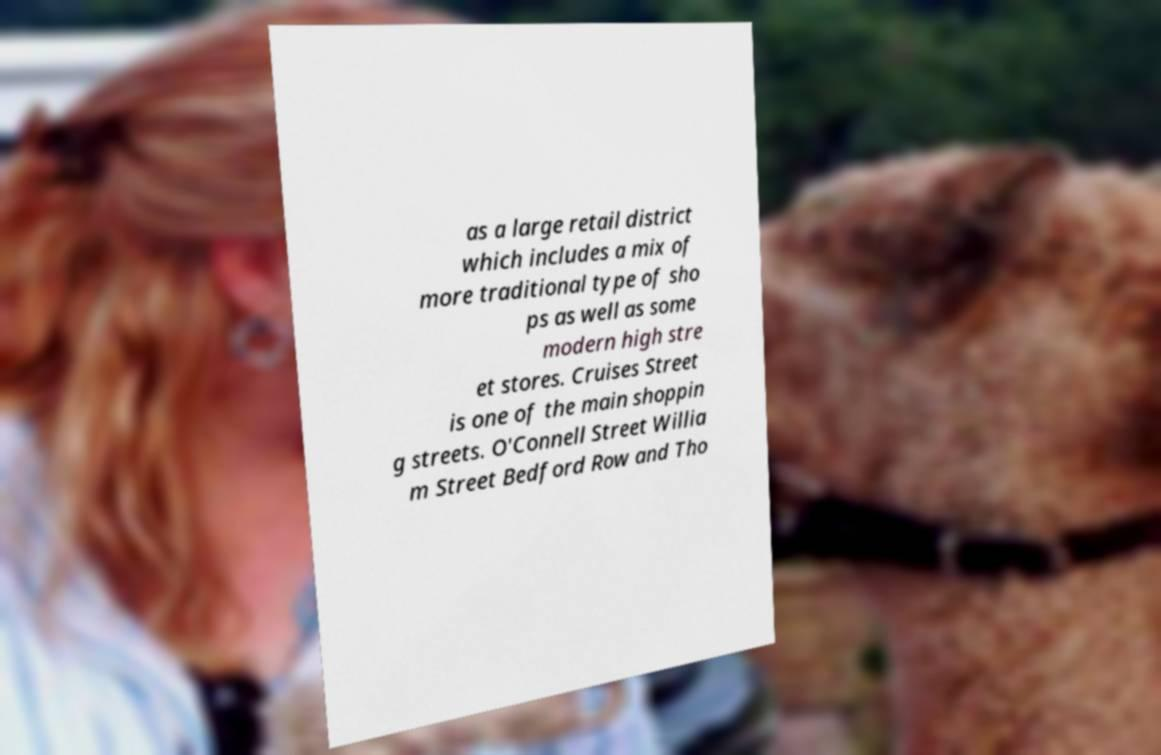Could you extract and type out the text from this image? as a large retail district which includes a mix of more traditional type of sho ps as well as some modern high stre et stores. Cruises Street is one of the main shoppin g streets. O'Connell Street Willia m Street Bedford Row and Tho 